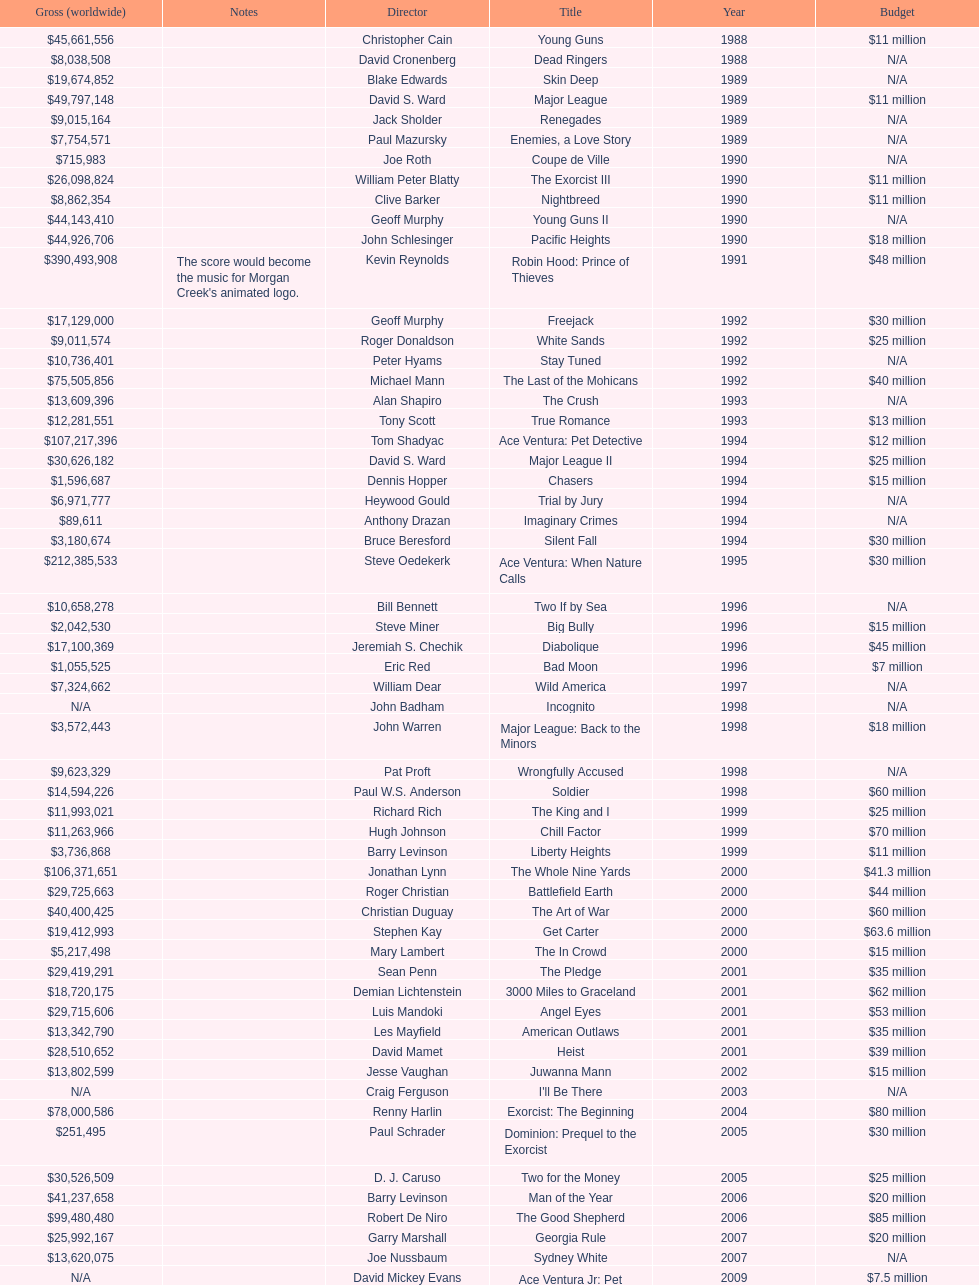What is the number of films directed by david s. ward? 2. 